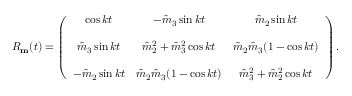Convert formula to latex. <formula><loc_0><loc_0><loc_500><loc_500>\begin{array} { r } { R _ { m } ( t ) = \left ( \begin{array} { c c c } { \cos k t } & { - \hat { m } _ { 3 } \sin k t } & { \hat { m } _ { 2 } \sin k t } \\ { \hat { m } _ { 3 } \sin k t } & { \hat { m } _ { 2 } ^ { 2 } + \hat { m } _ { 3 } ^ { 2 } \cos k t } & { \hat { m } _ { 2 } \hat { m } _ { 3 } ( 1 - \cos k t ) } \\ { - \hat { m } _ { 2 } \sin k t } & { \hat { m } _ { 2 } \hat { m } _ { 3 } ( 1 - \cos k t ) } & { \hat { m } _ { 3 } ^ { 2 } + \hat { m } _ { 2 } ^ { 2 } \cos k t } \end{array} \right ) . } \end{array}</formula> 